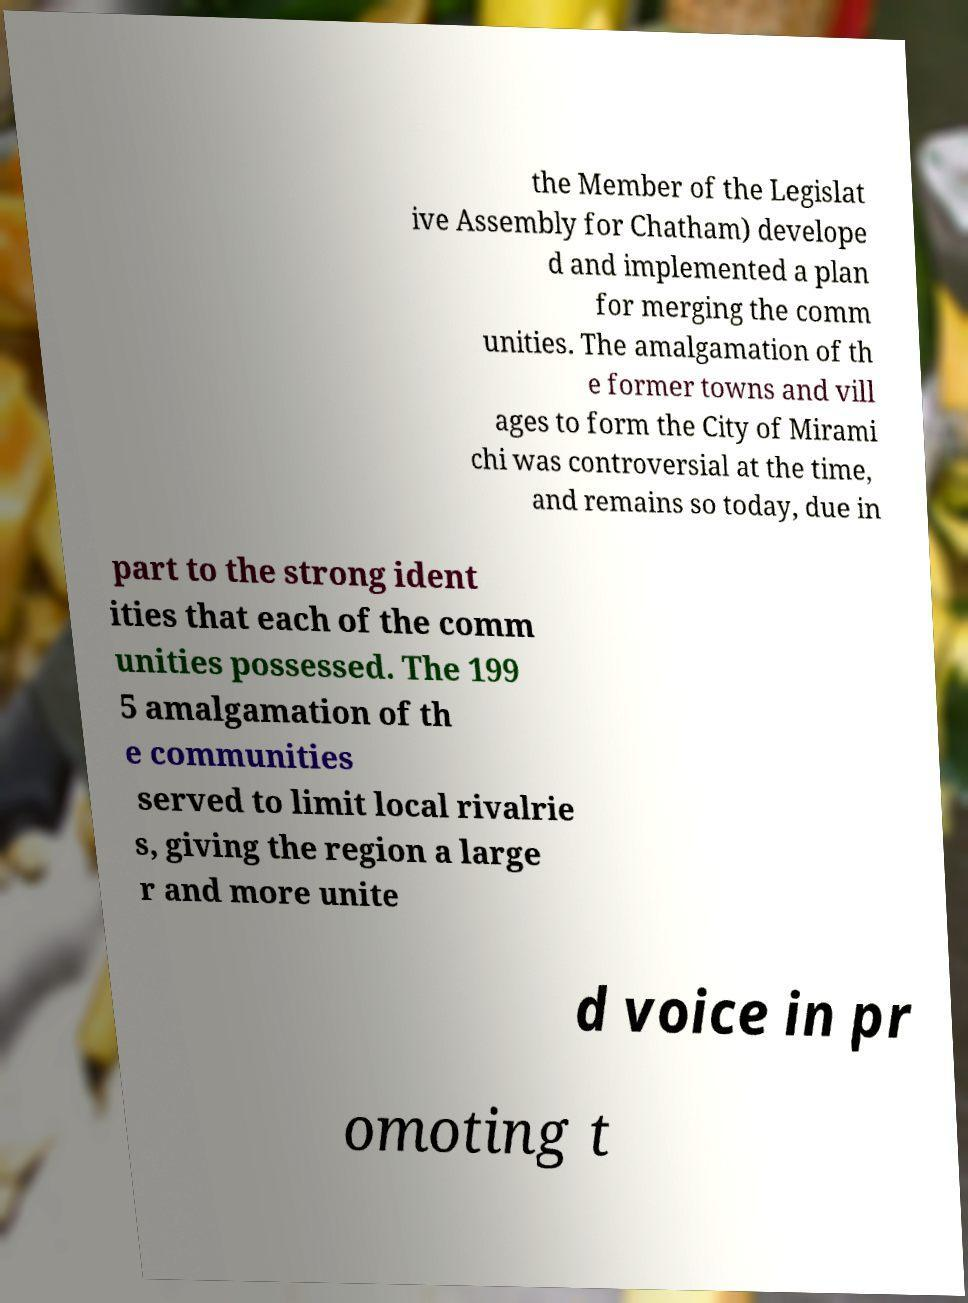Could you extract and type out the text from this image? the Member of the Legislat ive Assembly for Chatham) develope d and implemented a plan for merging the comm unities. The amalgamation of th e former towns and vill ages to form the City of Mirami chi was controversial at the time, and remains so today, due in part to the strong ident ities that each of the comm unities possessed. The 199 5 amalgamation of th e communities served to limit local rivalrie s, giving the region a large r and more unite d voice in pr omoting t 